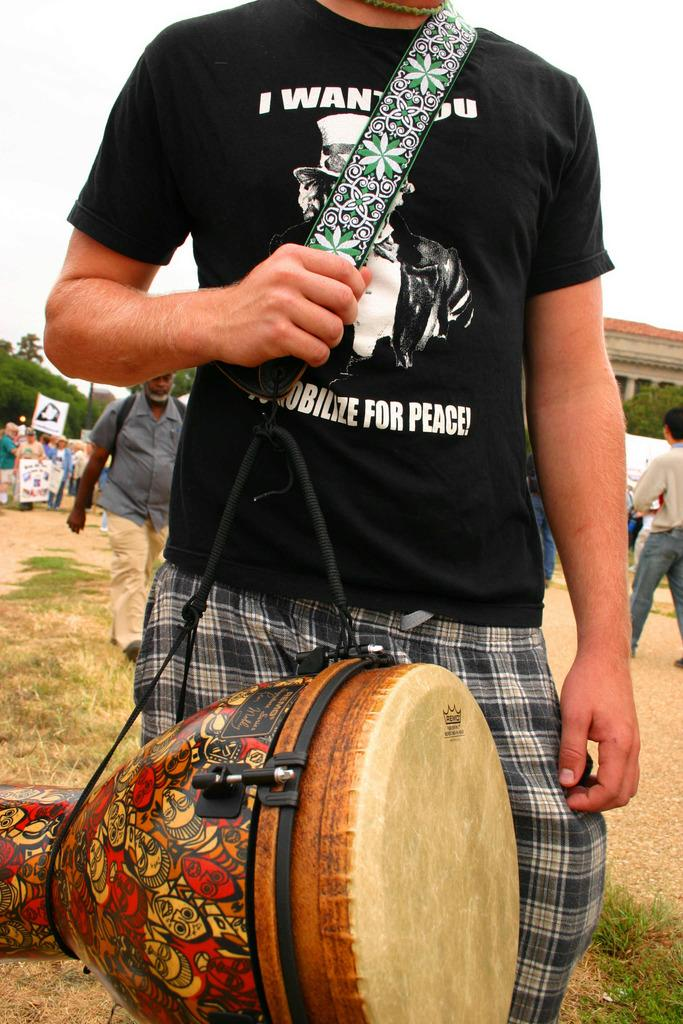How many people are in the image? There are many people in the image. What type of group are the people in the image part of? It is a musical band. What type of natural elements can be seen in the image? There is a tree and grass in the image. What is the color of the sky in the image? The sky is white in the image. What type of metal can be seen on the moon in the image? There is no moon or metal present in the image. Can you tell me how the self is interacting with the musical band in the image? There is no self or individual person mentioned in the image; it focuses on the musical band as a whole. 